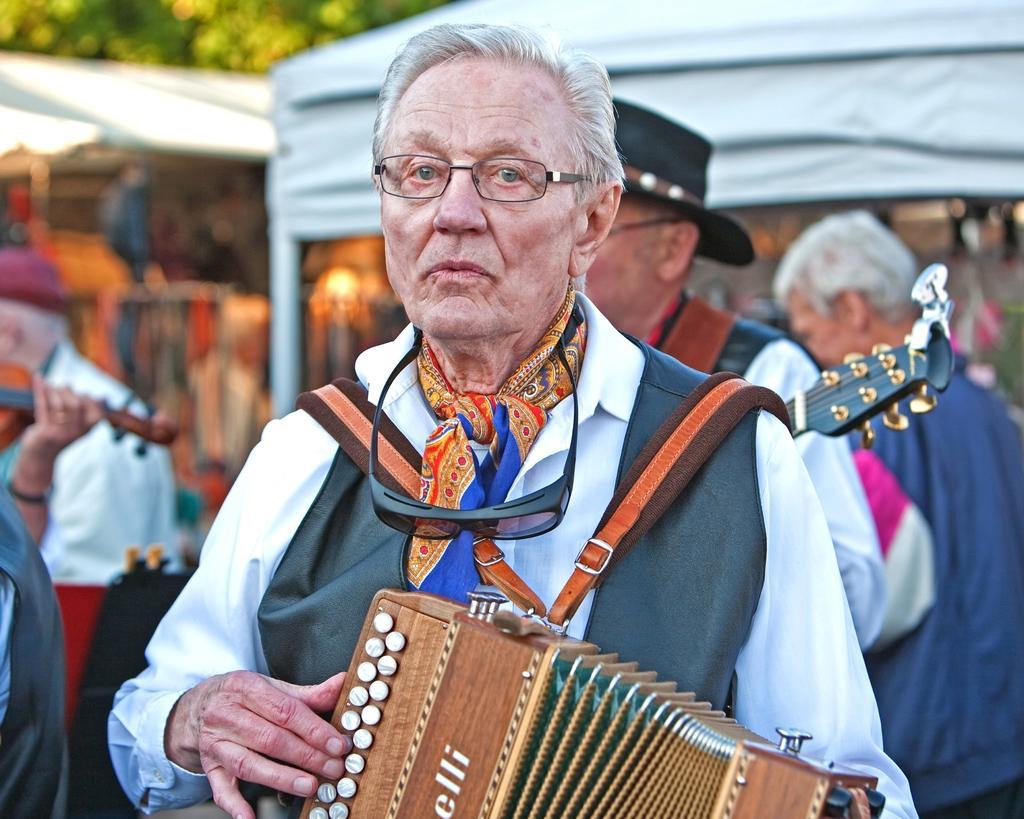Can you describe this image briefly? In this picture I can see a man in front who is standing and holding a musical instrument in his hands and in the background I see few more people who are holding musical instruments in their hands and I see few stalls and I see that it is blurred. 